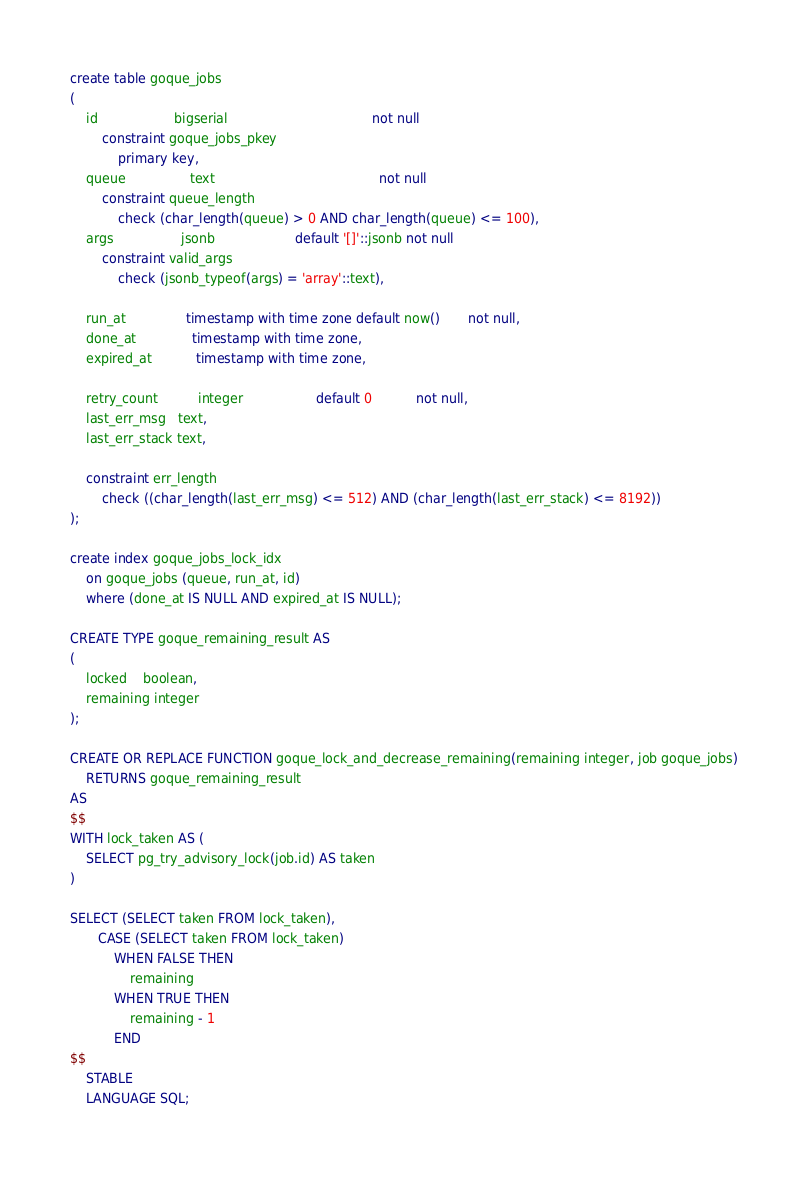<code> <loc_0><loc_0><loc_500><loc_500><_SQL_>create table goque_jobs
(
    id                   bigserial                                    not null
        constraint goque_jobs_pkey
            primary key,
    queue                text                                         not null
        constraint queue_length
            check (char_length(queue) > 0 AND char_length(queue) <= 100),
    args                 jsonb                    default '[]'::jsonb not null
        constraint valid_args
            check (jsonb_typeof(args) = 'array'::text),

    run_at               timestamp with time zone default now()       not null,
    done_at              timestamp with time zone,
    expired_at           timestamp with time zone,

    retry_count          integer                  default 0           not null,
    last_err_msg   text,
    last_err_stack text,

    constraint err_length
        check ((char_length(last_err_msg) <= 512) AND (char_length(last_err_stack) <= 8192))
);

create index goque_jobs_lock_idx
    on goque_jobs (queue, run_at, id)
    where (done_at IS NULL AND expired_at IS NULL);

CREATE TYPE goque_remaining_result AS
(
    locked    boolean,
    remaining integer
);

CREATE OR REPLACE FUNCTION goque_lock_and_decrease_remaining(remaining integer, job goque_jobs)
    RETURNS goque_remaining_result
AS
$$
WITH lock_taken AS (
    SELECT pg_try_advisory_lock(job.id) AS taken
)

SELECT (SELECT taken FROM lock_taken),
       CASE (SELECT taken FROM lock_taken)
           WHEN FALSE THEN
               remaining
           WHEN TRUE THEN
               remaining - 1
           END
$$
    STABLE
    LANGUAGE SQL;
</code> 